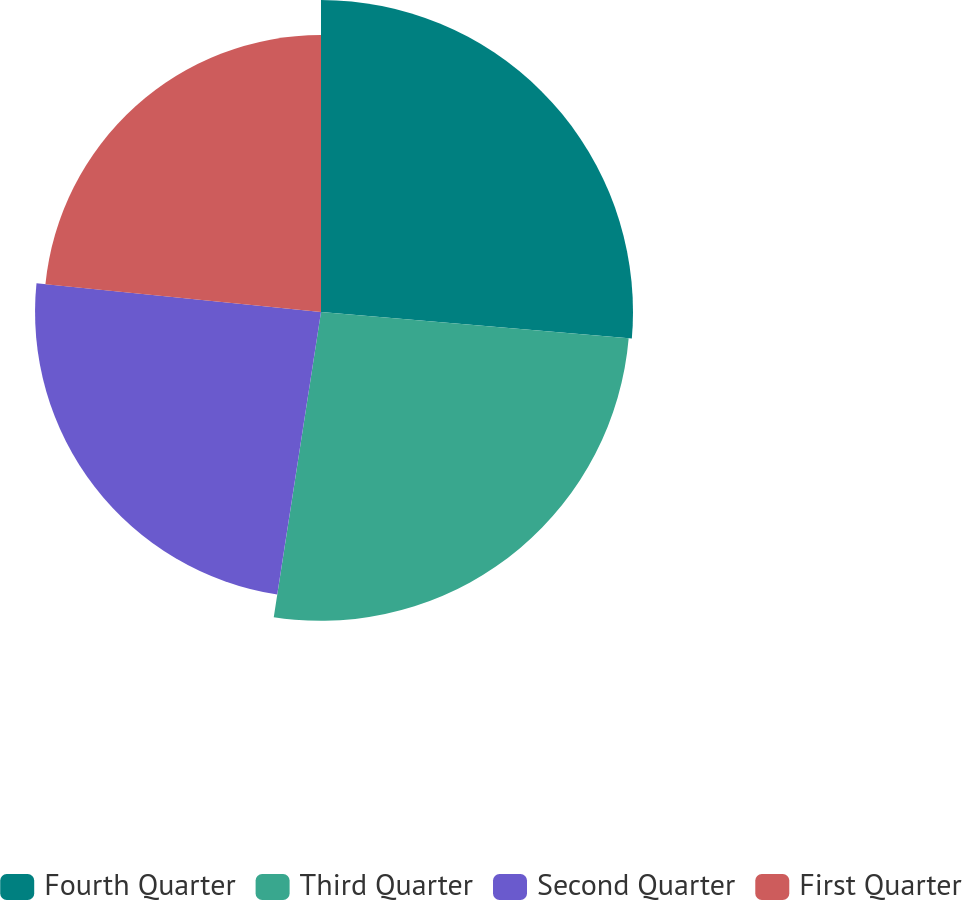<chart> <loc_0><loc_0><loc_500><loc_500><pie_chart><fcel>Fourth Quarter<fcel>Third Quarter<fcel>Second Quarter<fcel>First Quarter<nl><fcel>26.36%<fcel>26.09%<fcel>24.16%<fcel>23.4%<nl></chart> 